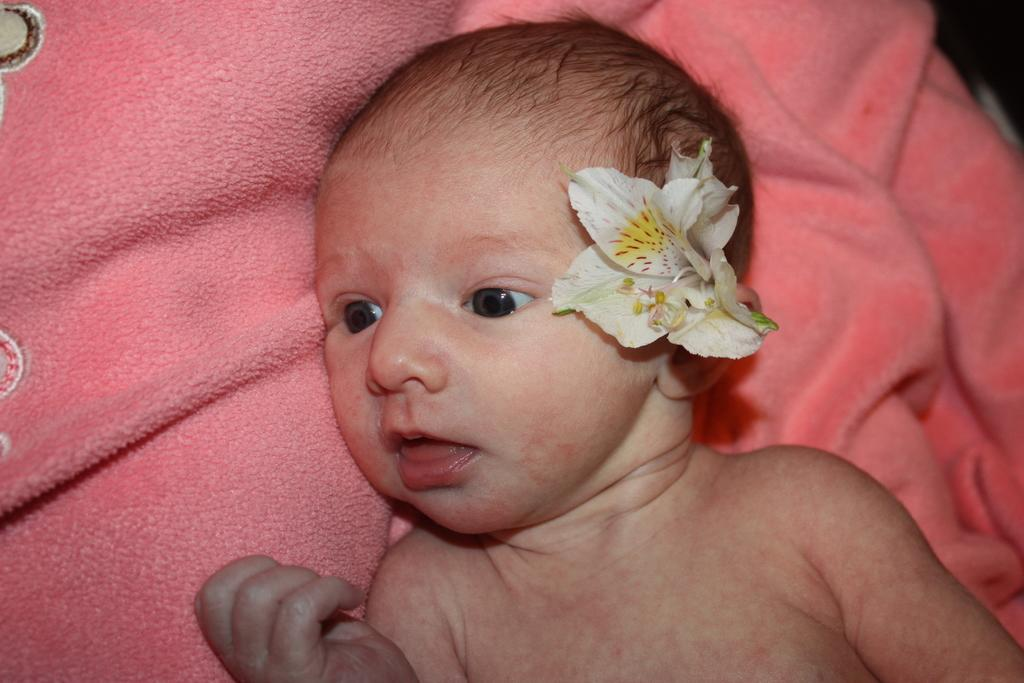What is the main subject of the picture? The main subject of the picture is a baby. Where is the baby located in the image? The baby is lying on a bed. What is covering the bed? There is a bed sheet on the bed. What can be seen in the center of the image? There is a flower in the center of the image. How is the flower positioned in the image? The flower is kept on the ear. What is the name of the baby in the image? The provided facts do not mention the name of the baby, so we cannot determine it from the image. What time of day is depicted in the image? The provided facts do not mention the time of day, so we cannot determine it from the image. 